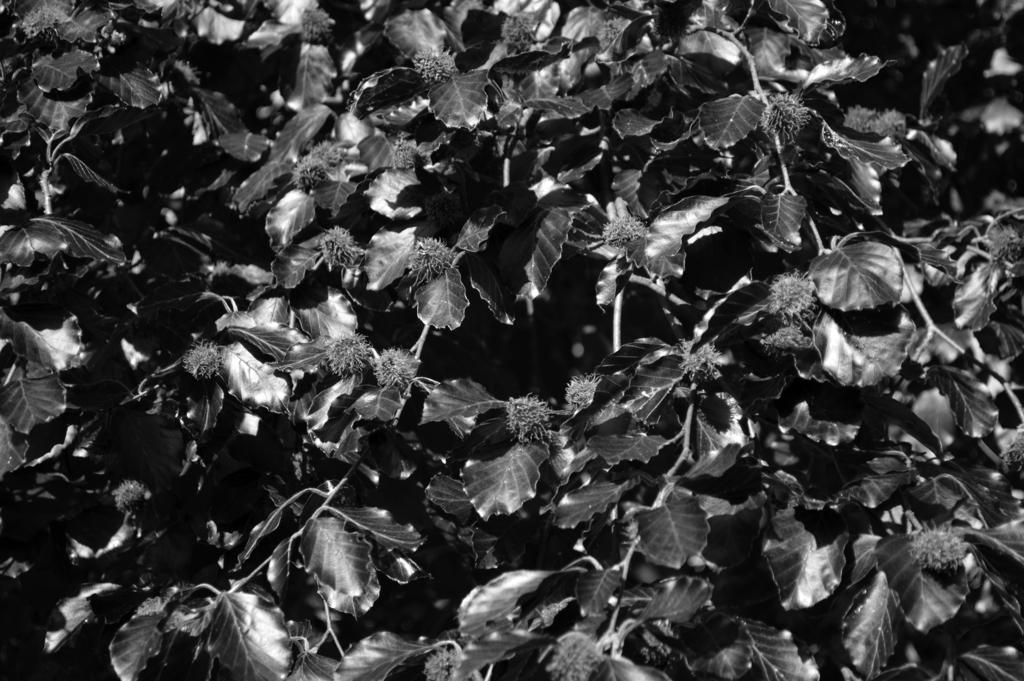What is the color scheme of the image? The image is black and white. What type of plant material is present in the image? There are leaves in the image. Are the leaves connected to any other part of the plant? Yes, the leaves are attached to stems. Can you see any bananas hanging from the stems in the image? No, there are no bananas present in the image. What type of wire is used to support the leaves in the image? There is no wire visible in the image; the leaves are attached to stems. 